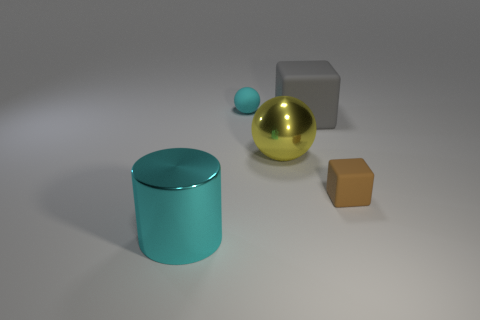Add 2 cyan shiny cylinders. How many objects exist? 7 Subtract all balls. How many objects are left? 3 Add 1 cyan objects. How many cyan objects are left? 3 Add 4 yellow shiny spheres. How many yellow shiny spheres exist? 5 Subtract 0 red cylinders. How many objects are left? 5 Subtract all gray things. Subtract all large shiny balls. How many objects are left? 3 